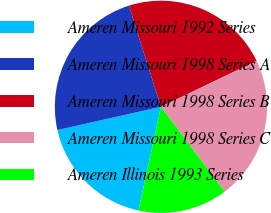<chart> <loc_0><loc_0><loc_500><loc_500><pie_chart><fcel>Ameren Missouri 1992 Series<fcel>Ameren Missouri 1998 Series A<fcel>Ameren Missouri 1998 Series B<fcel>Ameren Missouri 1998 Series C<fcel>Ameren Illinois 1993 Series<nl><fcel>18.08%<fcel>23.64%<fcel>22.76%<fcel>21.87%<fcel>13.65%<nl></chart> 